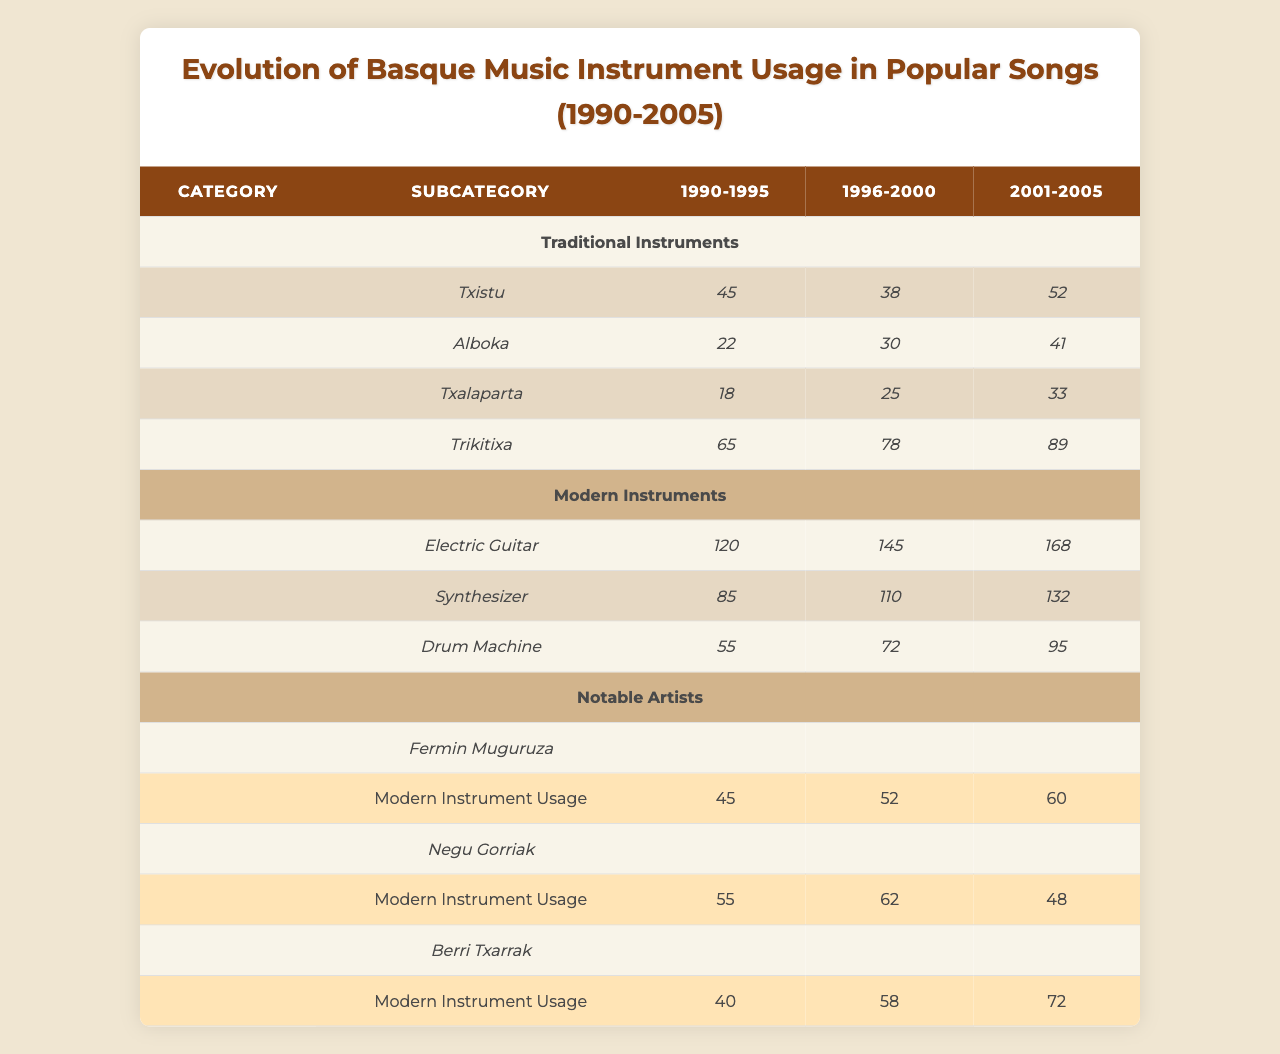What was the usage of the Txistu in the years 1996-2000? According to the table, the usage of the Txistu in the years 1996-2000 is 38.
Answer: 38 Which traditional instrument had the highest usage in 2001-2005? The instrument with the highest usage in 2001-2005 is Trikitixa, with a usage of 89.
Answer: Trikitixa What was the total usage of the Electric Guitar from 1990-2005? The total usage of the Electric Guitar can be calculated as 120 + 145 + 168 = 433.
Answer: 433 Did Fermin Muguruza use more traditional instruments than modern instruments in 1990-1995? To determine this, we look at his usage: 15 for traditional and 45 for modern instruments. Since 15 is less than 45, he did not use more traditional instruments.
Answer: No What was the change in usage of the Alboka from 1990-1995 to 2001-2005? The usage of the Alboka in 1990-1995 was 22, and in 2001-2005 it was 41. The change is calculated as 41 - 22 = 19, indicating an increase.
Answer: 19 Which modern instrument had the lowest usage in 1990-1995? By scanning the table for modern instruments, the lowest usage is for the Drum Machine at 55 in the period of 1990-1995.
Answer: Drum Machine What is the average traditional instrument usage for Berri Txarrak during the years 1990-2005? To find the average, we sum the values for the years: 8 (1990-1995) + 15 (1996-2000) + 25 (2001-2005) = 48, and divide by the number of periods (3): 48/3 = 16.
Answer: 16 Did Negu Gorriak show an overall increase in modern instrument usage from 1990-2005? Negu Gorriak's modern instrument usage was 55 (1990-1995), 62 (1996-2000), and 48 (2001-2005). The usage increased from the first to the second period, but decreased in the last, so overall, there was not a consistent increase.
Answer: No What was the highest usage of the Synthesizer during 1990-2005? The highest usage of the Synthesizer was 132 in the period of 2001-2005.
Answer: 132 Which traditional instrument usage demonstrated the biggest increase between 1990-1995 and 2001-2005? Looking at the increases for each traditional instrument, Txalaparta increased from 18 to 33, an increase of 15. Thus, Trikitixa saw the biggest increase from 65 to 89, which is 24.
Answer: Trikitixa 